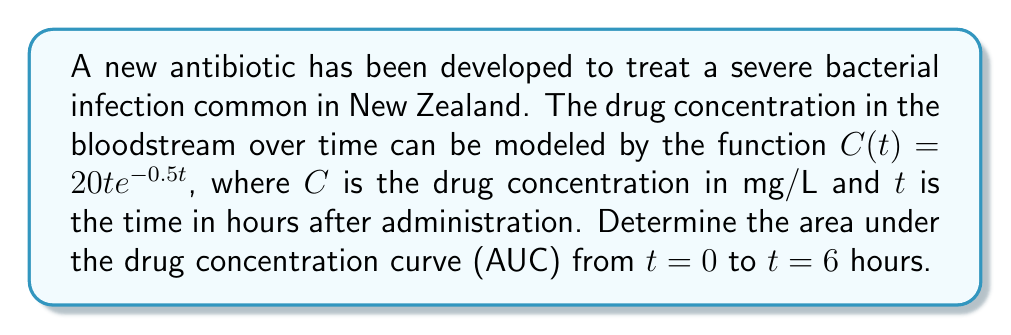Can you answer this question? To find the area under the curve (AUC), we need to integrate the given function from $t = 0$ to $t = 6$. Let's approach this step-by-step:

1) The integral we need to evaluate is:

   $$\int_0^6 20t e^{-0.5t} dt$$

2) This integral can be solved using integration by parts. Let $u = t$ and $dv = 20e^{-0.5t}dt$. Then:

   $du = dt$
   $v = -40e^{-0.5t}$

3) Applying the integration by parts formula:

   $$\int u dv = uv - \int v du$$

   We get:

   $$[-40te^{-0.5t}]_0^6 + \int_0^6 40e^{-0.5t} dt$$

4) Evaluating the first part:

   $[-40te^{-0.5t}]_0^6 = -40(6)e^{-0.5(6)} - (-40(0)e^{-0.5(0)}) = -240e^{-3}$

5) For the second part, we integrate:

   $$\int_0^6 40e^{-0.5t} dt = [-80e^{-0.5t}]_0^6 = -80e^{-3} - (-80) = 80 - 80e^{-3}$$

6) Combining the results:

   $$-240e^{-3} + 80 - 80e^{-3} = 80 - 320e^{-3}$$

7) Simplifying:

   $$80 - 320e^{-3} \approx 74.26$$

Therefore, the area under the curve from $t = 0$ to $t = 6$ is approximately 74.26 mg⋅h/L.
Answer: $80 - 320e^{-3} \approx 74.26$ mg⋅h/L 